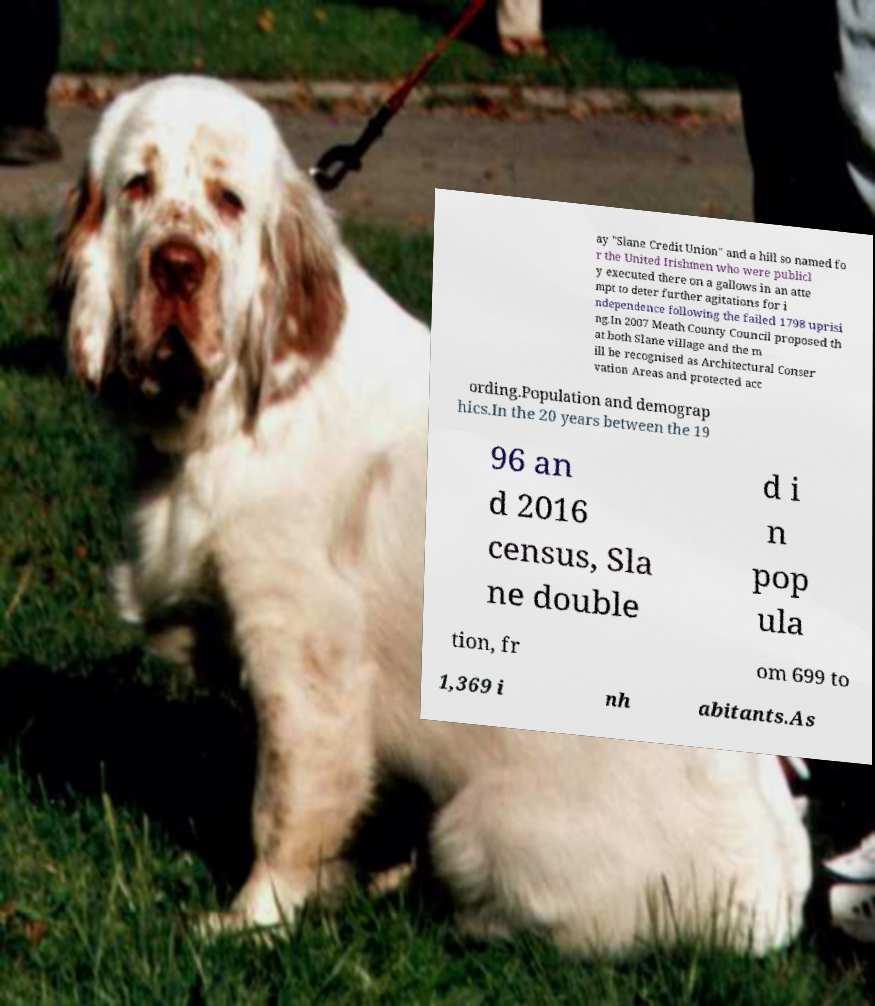For documentation purposes, I need the text within this image transcribed. Could you provide that? ay "Slane Credit Union" and a hill so named fo r the United Irishmen who were publicl y executed there on a gallows in an atte mpt to deter further agitations for i ndependence following the failed 1798 uprisi ng.In 2007 Meath County Council proposed th at both Slane village and the m ill be recognised as Architectural Conser vation Areas and protected acc ording.Population and demograp hics.In the 20 years between the 19 96 an d 2016 census, Sla ne double d i n pop ula tion, fr om 699 to 1,369 i nh abitants.As 